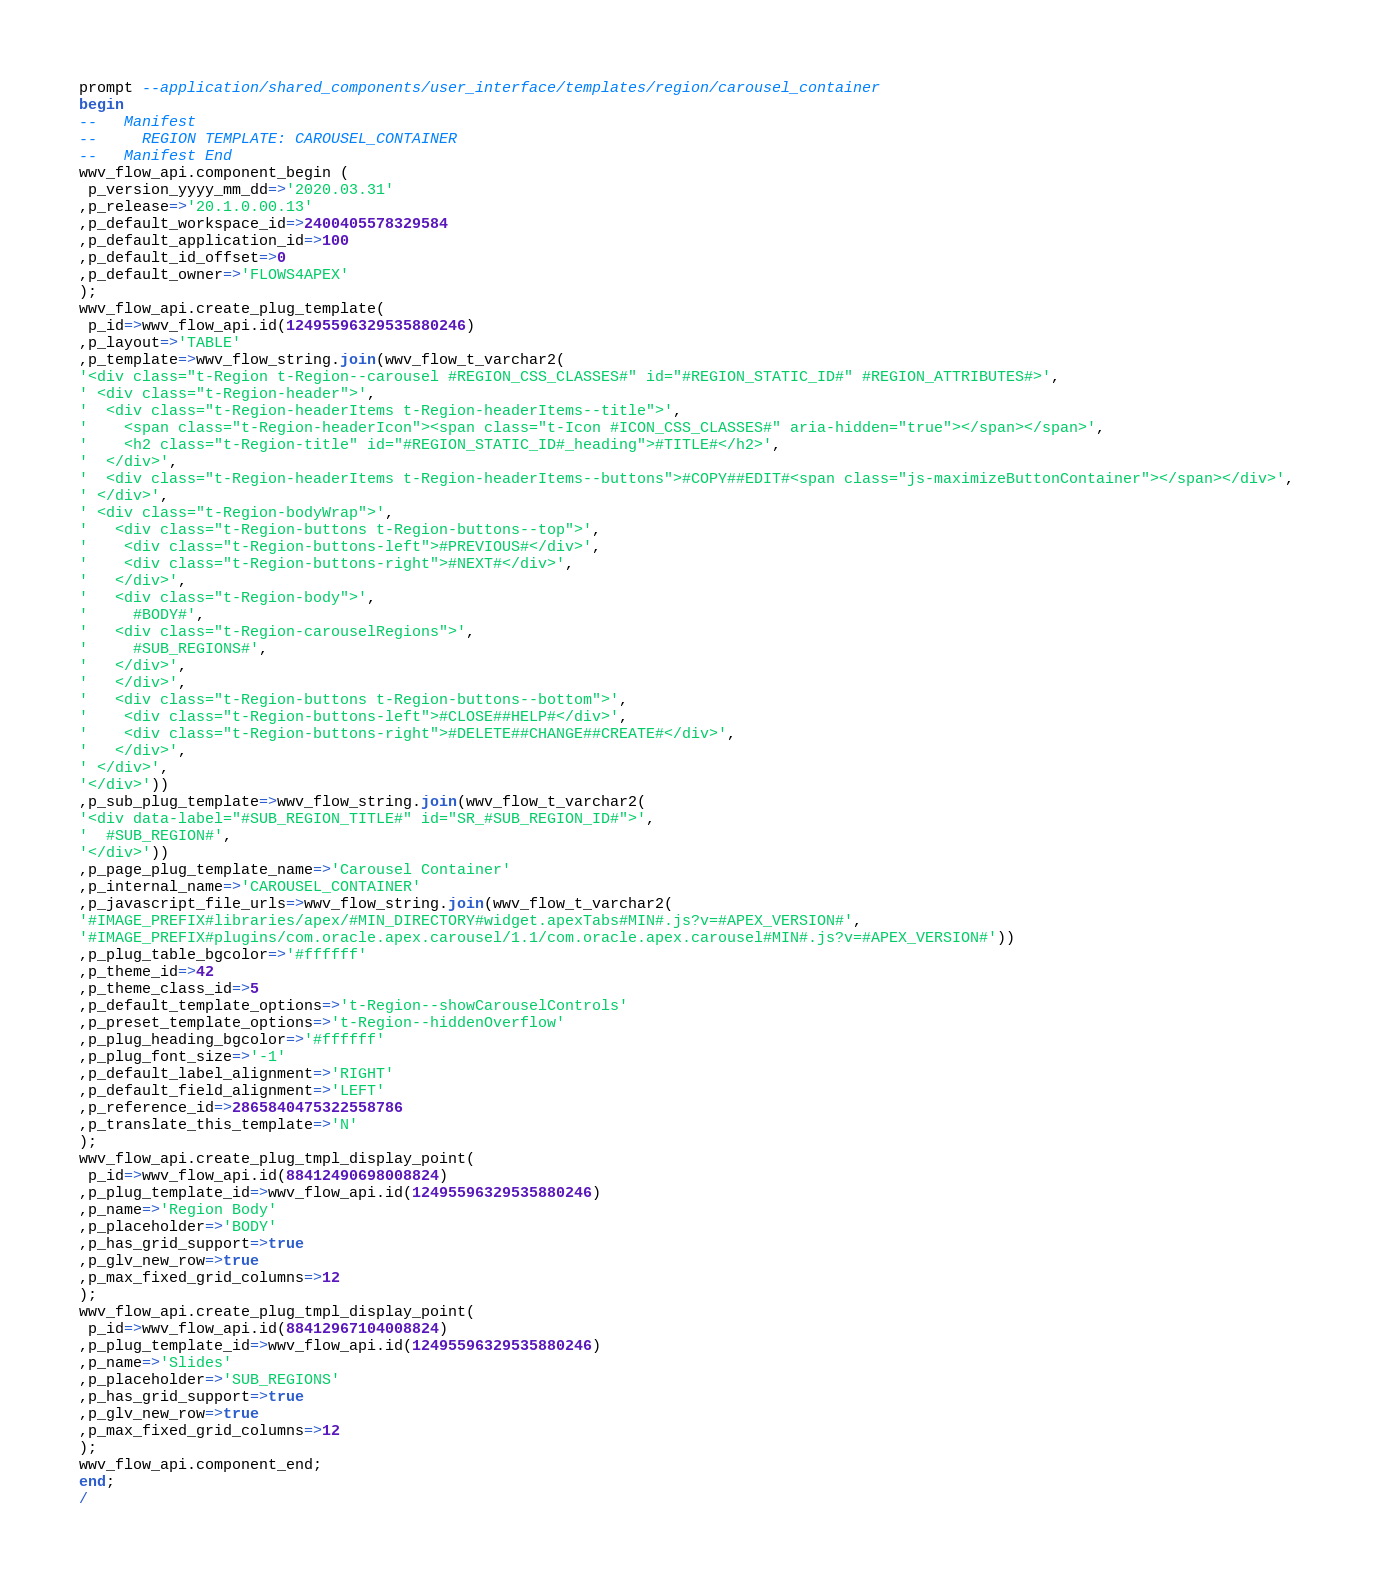Convert code to text. <code><loc_0><loc_0><loc_500><loc_500><_SQL_>prompt --application/shared_components/user_interface/templates/region/carousel_container
begin
--   Manifest
--     REGION TEMPLATE: CAROUSEL_CONTAINER
--   Manifest End
wwv_flow_api.component_begin (
 p_version_yyyy_mm_dd=>'2020.03.31'
,p_release=>'20.1.0.00.13'
,p_default_workspace_id=>2400405578329584
,p_default_application_id=>100
,p_default_id_offset=>0
,p_default_owner=>'FLOWS4APEX'
);
wwv_flow_api.create_plug_template(
 p_id=>wwv_flow_api.id(12495596329535880246)
,p_layout=>'TABLE'
,p_template=>wwv_flow_string.join(wwv_flow_t_varchar2(
'<div class="t-Region t-Region--carousel #REGION_CSS_CLASSES#" id="#REGION_STATIC_ID#" #REGION_ATTRIBUTES#>',
' <div class="t-Region-header">',
'  <div class="t-Region-headerItems t-Region-headerItems--title">',
'    <span class="t-Region-headerIcon"><span class="t-Icon #ICON_CSS_CLASSES#" aria-hidden="true"></span></span>',
'    <h2 class="t-Region-title" id="#REGION_STATIC_ID#_heading">#TITLE#</h2>',
'  </div>',
'  <div class="t-Region-headerItems t-Region-headerItems--buttons">#COPY##EDIT#<span class="js-maximizeButtonContainer"></span></div>',
' </div>',
' <div class="t-Region-bodyWrap">',
'   <div class="t-Region-buttons t-Region-buttons--top">',
'    <div class="t-Region-buttons-left">#PREVIOUS#</div>',
'    <div class="t-Region-buttons-right">#NEXT#</div>',
'   </div>',
'   <div class="t-Region-body">',
'     #BODY#',
'   <div class="t-Region-carouselRegions">',
'     #SUB_REGIONS#',
'   </div>',
'   </div>',
'   <div class="t-Region-buttons t-Region-buttons--bottom">',
'    <div class="t-Region-buttons-left">#CLOSE##HELP#</div>',
'    <div class="t-Region-buttons-right">#DELETE##CHANGE##CREATE#</div>',
'   </div>',
' </div>',
'</div>'))
,p_sub_plug_template=>wwv_flow_string.join(wwv_flow_t_varchar2(
'<div data-label="#SUB_REGION_TITLE#" id="SR_#SUB_REGION_ID#">',
'  #SUB_REGION#',
'</div>'))
,p_page_plug_template_name=>'Carousel Container'
,p_internal_name=>'CAROUSEL_CONTAINER'
,p_javascript_file_urls=>wwv_flow_string.join(wwv_flow_t_varchar2(
'#IMAGE_PREFIX#libraries/apex/#MIN_DIRECTORY#widget.apexTabs#MIN#.js?v=#APEX_VERSION#',
'#IMAGE_PREFIX#plugins/com.oracle.apex.carousel/1.1/com.oracle.apex.carousel#MIN#.js?v=#APEX_VERSION#'))
,p_plug_table_bgcolor=>'#ffffff'
,p_theme_id=>42
,p_theme_class_id=>5
,p_default_template_options=>'t-Region--showCarouselControls'
,p_preset_template_options=>'t-Region--hiddenOverflow'
,p_plug_heading_bgcolor=>'#ffffff'
,p_plug_font_size=>'-1'
,p_default_label_alignment=>'RIGHT'
,p_default_field_alignment=>'LEFT'
,p_reference_id=>2865840475322558786
,p_translate_this_template=>'N'
);
wwv_flow_api.create_plug_tmpl_display_point(
 p_id=>wwv_flow_api.id(88412490698008824)
,p_plug_template_id=>wwv_flow_api.id(12495596329535880246)
,p_name=>'Region Body'
,p_placeholder=>'BODY'
,p_has_grid_support=>true
,p_glv_new_row=>true
,p_max_fixed_grid_columns=>12
);
wwv_flow_api.create_plug_tmpl_display_point(
 p_id=>wwv_flow_api.id(88412967104008824)
,p_plug_template_id=>wwv_flow_api.id(12495596329535880246)
,p_name=>'Slides'
,p_placeholder=>'SUB_REGIONS'
,p_has_grid_support=>true
,p_glv_new_row=>true
,p_max_fixed_grid_columns=>12
);
wwv_flow_api.component_end;
end;
/
</code> 